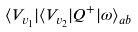Convert formula to latex. <formula><loc_0><loc_0><loc_500><loc_500>\langle V _ { v _ { 1 } } | \langle V _ { v _ { 2 } } | Q ^ { + } | \omega \rangle _ { a b }</formula> 